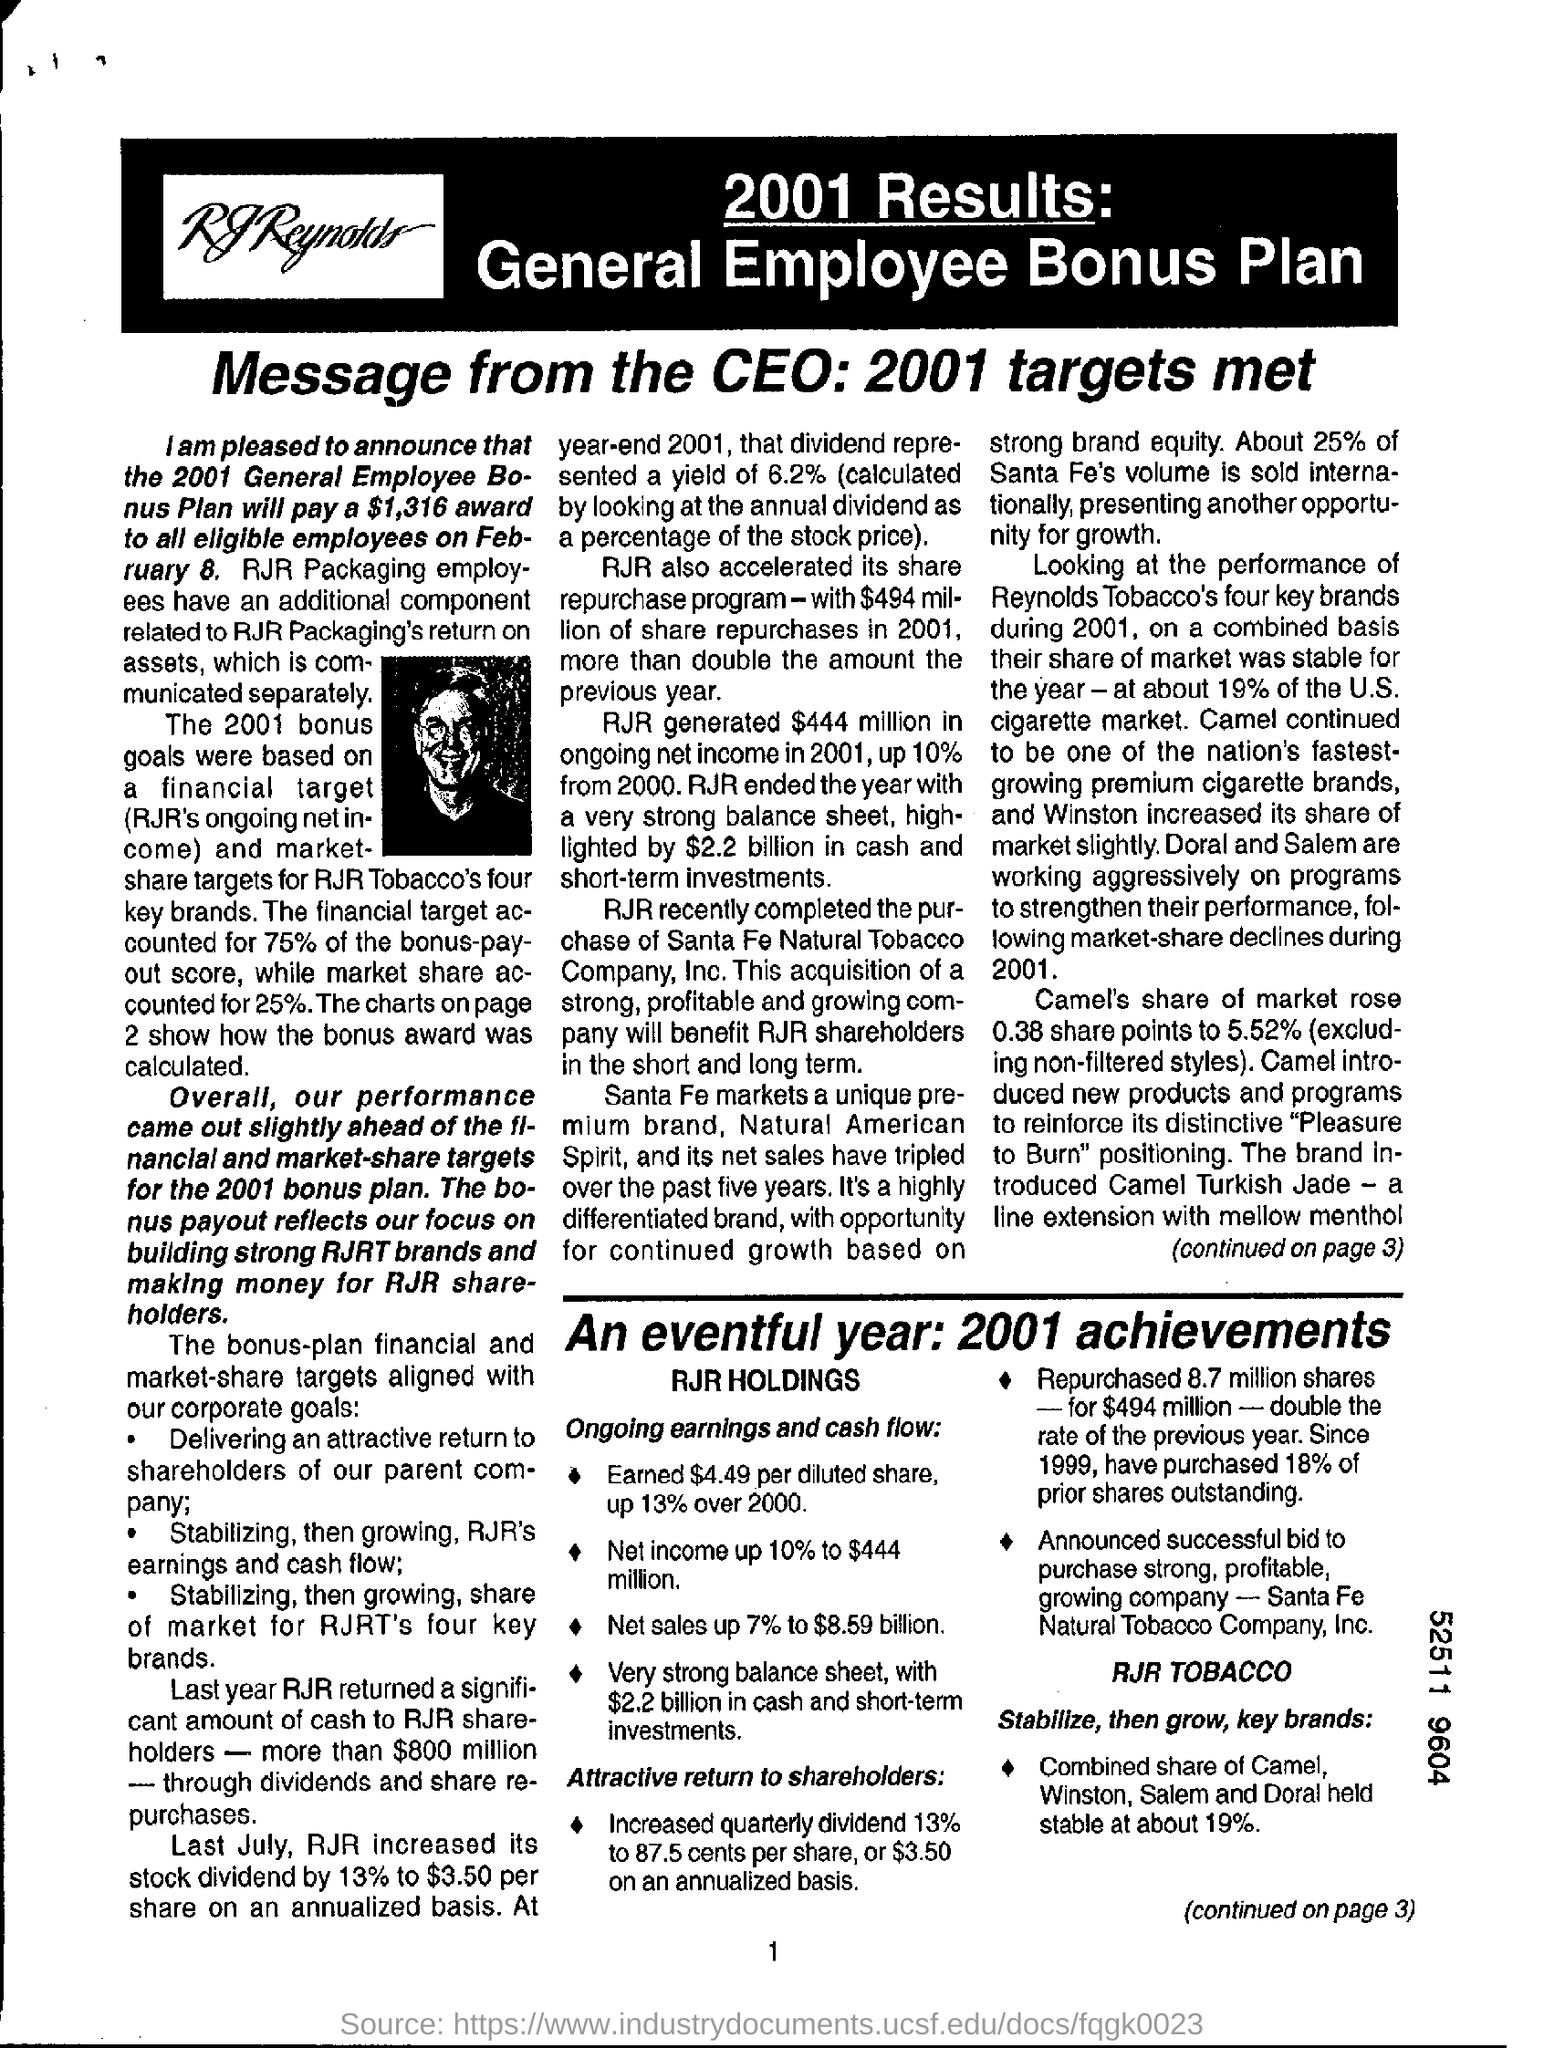Outline some significant characteristics in this image. This message is from the CEO. 